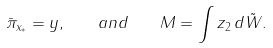<formula> <loc_0><loc_0><loc_500><loc_500>\bar { \pi } _ { x _ { * } } = y , \quad a n d \quad M = \int z _ { 2 } \, d \tilde { W } .</formula> 